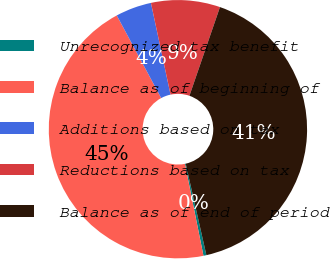<chart> <loc_0><loc_0><loc_500><loc_500><pie_chart><fcel>Unrecognized tax benefit<fcel>Balance as of beginning of<fcel>Additions based on tax<fcel>Reductions based on tax<fcel>Balance as of end of period<nl><fcel>0.37%<fcel>45.32%<fcel>4.5%<fcel>8.63%<fcel>41.19%<nl></chart> 